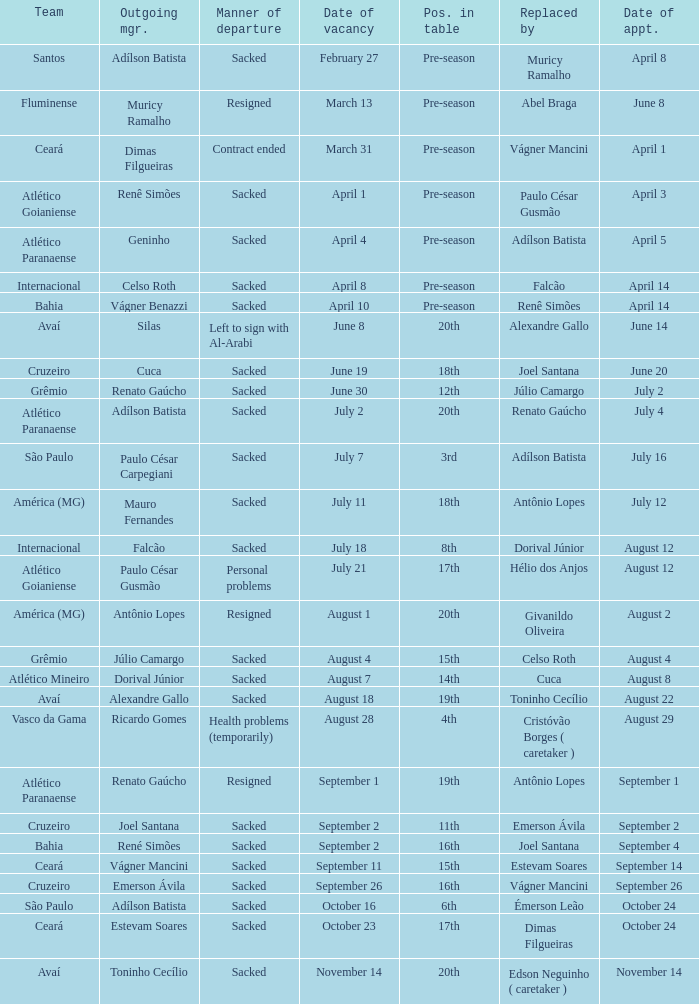Who was replaced as manager on June 20? Cuca. 